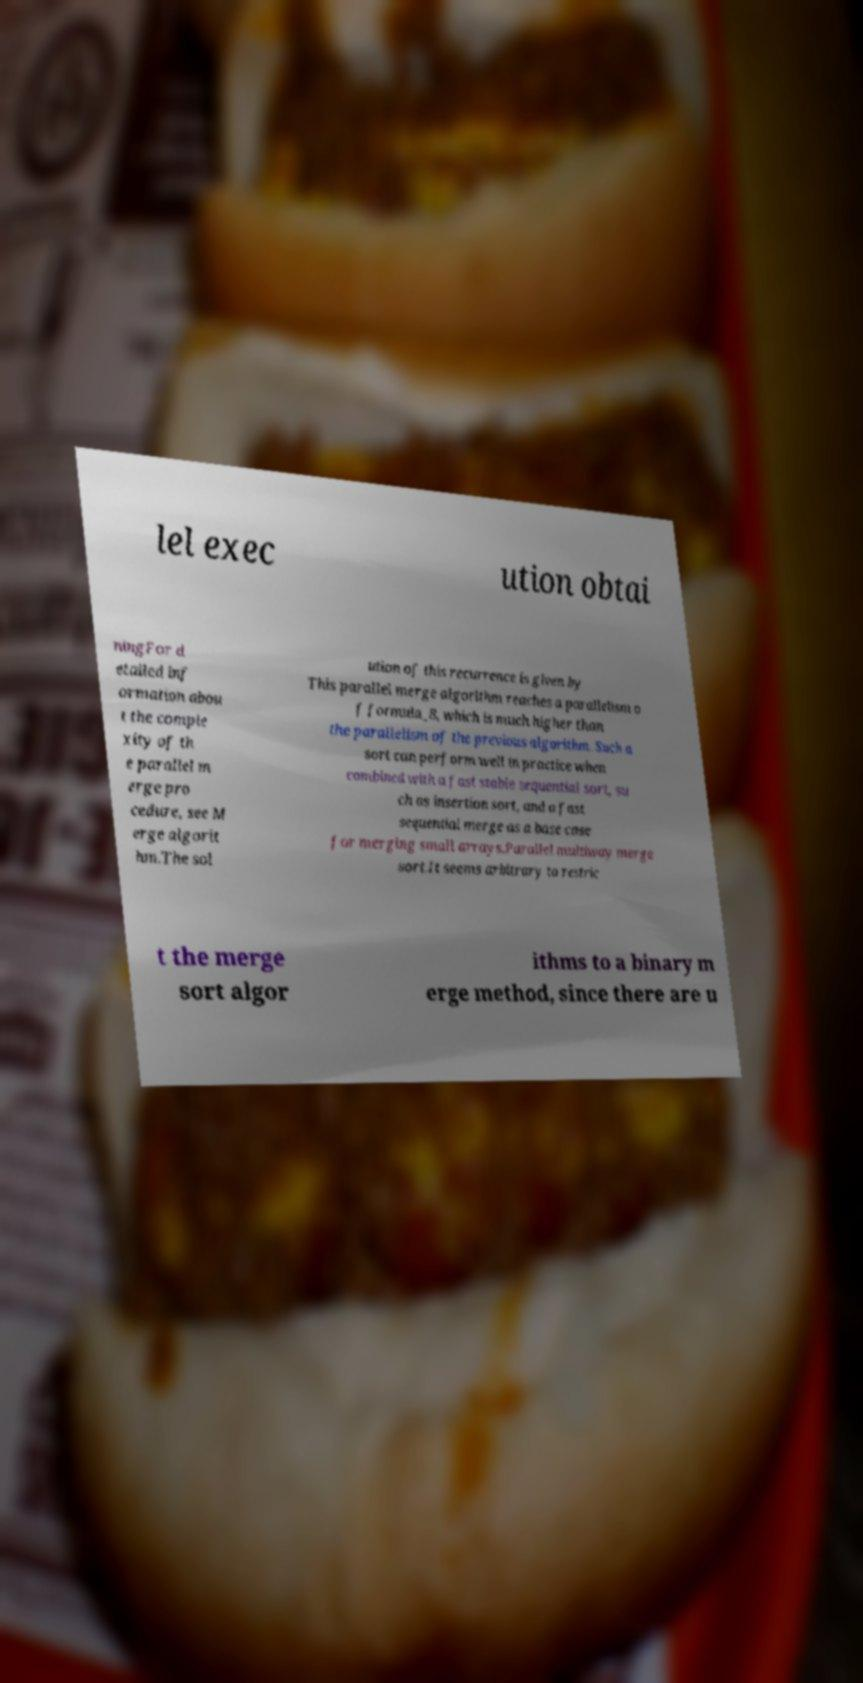Please identify and transcribe the text found in this image. lel exec ution obtai ningFor d etailed inf ormation abou t the comple xity of th e parallel m erge pro cedure, see M erge algorit hm.The sol ution of this recurrence is given by This parallel merge algorithm reaches a parallelism o f formula_8, which is much higher than the parallelism of the previous algorithm. Such a sort can perform well in practice when combined with a fast stable sequential sort, su ch as insertion sort, and a fast sequential merge as a base case for merging small arrays.Parallel multiway merge sort.It seems arbitrary to restric t the merge sort algor ithms to a binary m erge method, since there are u 